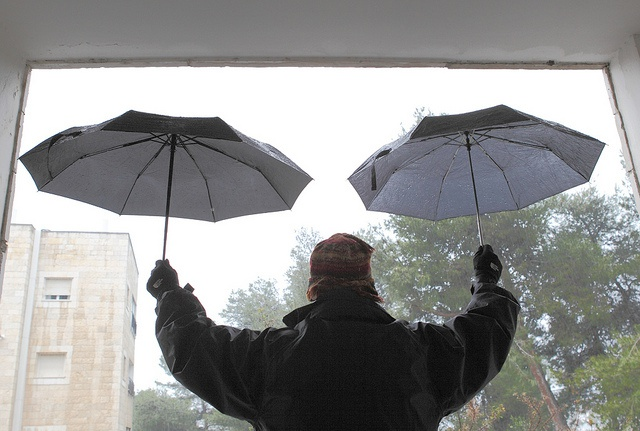Describe the objects in this image and their specific colors. I can see people in gray, black, darkgray, and white tones, umbrella in gray, black, darkgray, and white tones, and umbrella in gray and black tones in this image. 